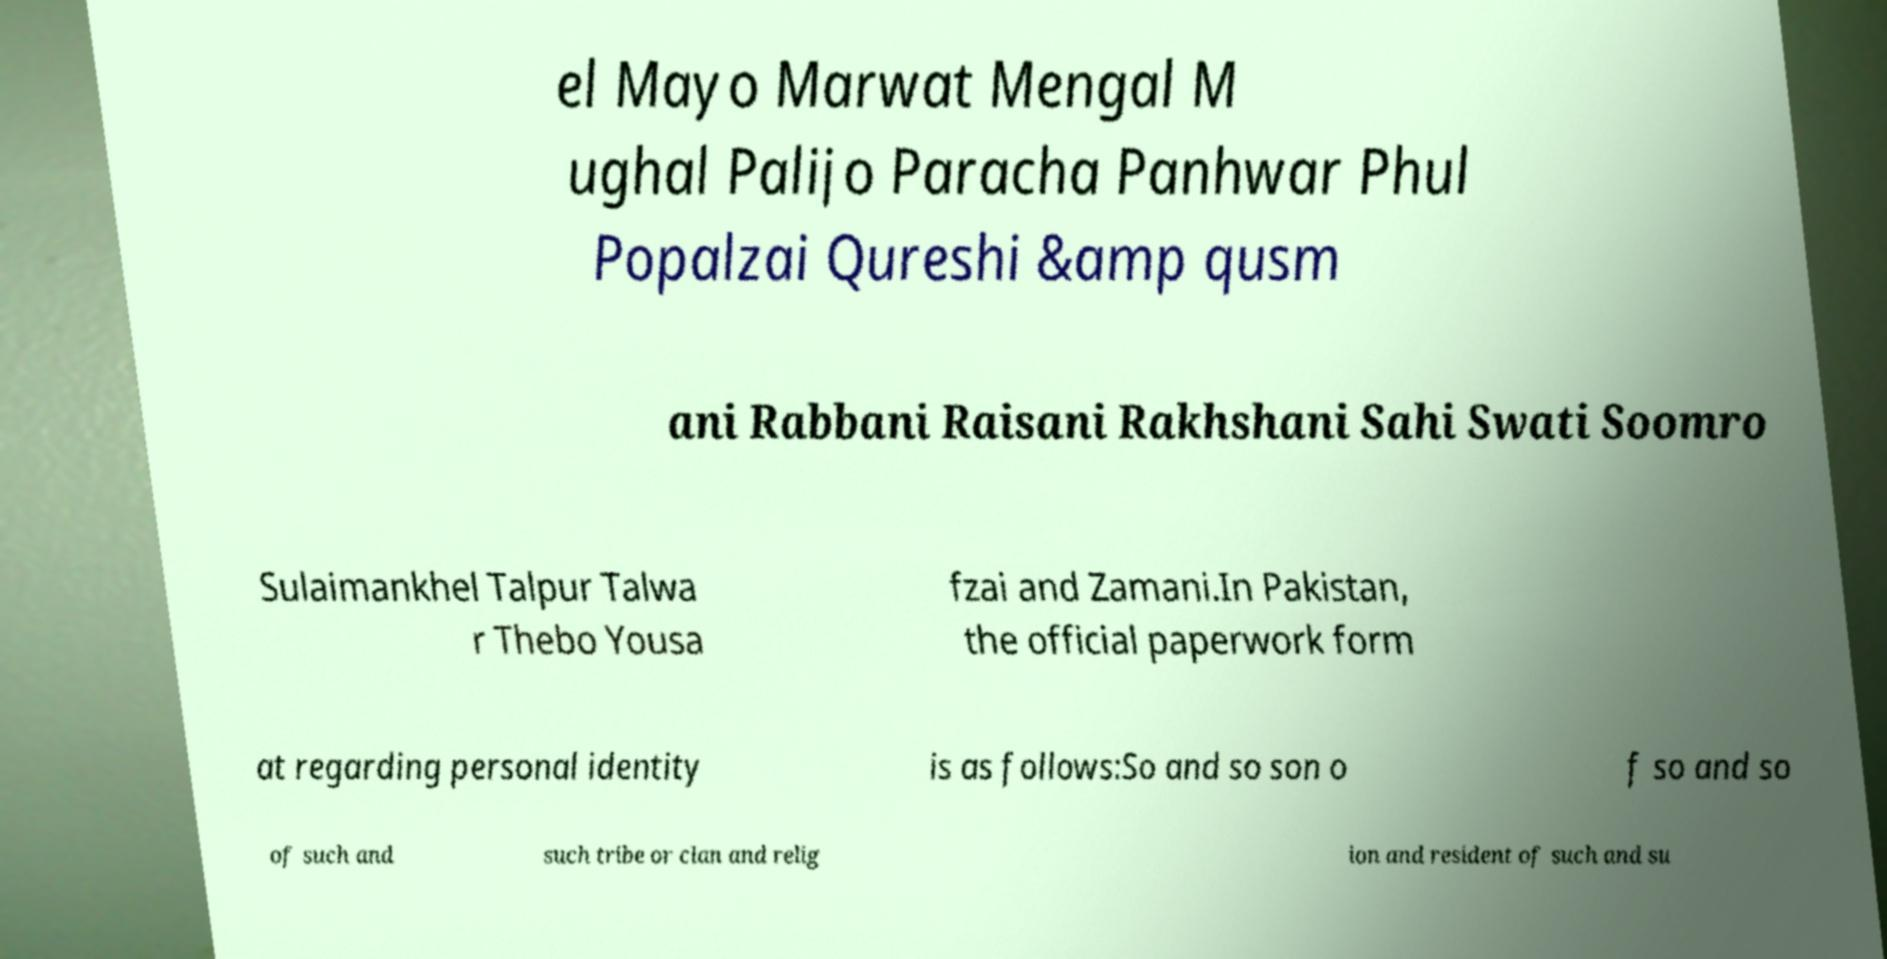What messages or text are displayed in this image? I need them in a readable, typed format. el Mayo Marwat Mengal M ughal Palijo Paracha Panhwar Phul Popalzai Qureshi &amp qusm ani Rabbani Raisani Rakhshani Sahi Swati Soomro Sulaimankhel Talpur Talwa r Thebo Yousa fzai and Zamani.In Pakistan, the official paperwork form at regarding personal identity is as follows:So and so son o f so and so of such and such tribe or clan and relig ion and resident of such and su 